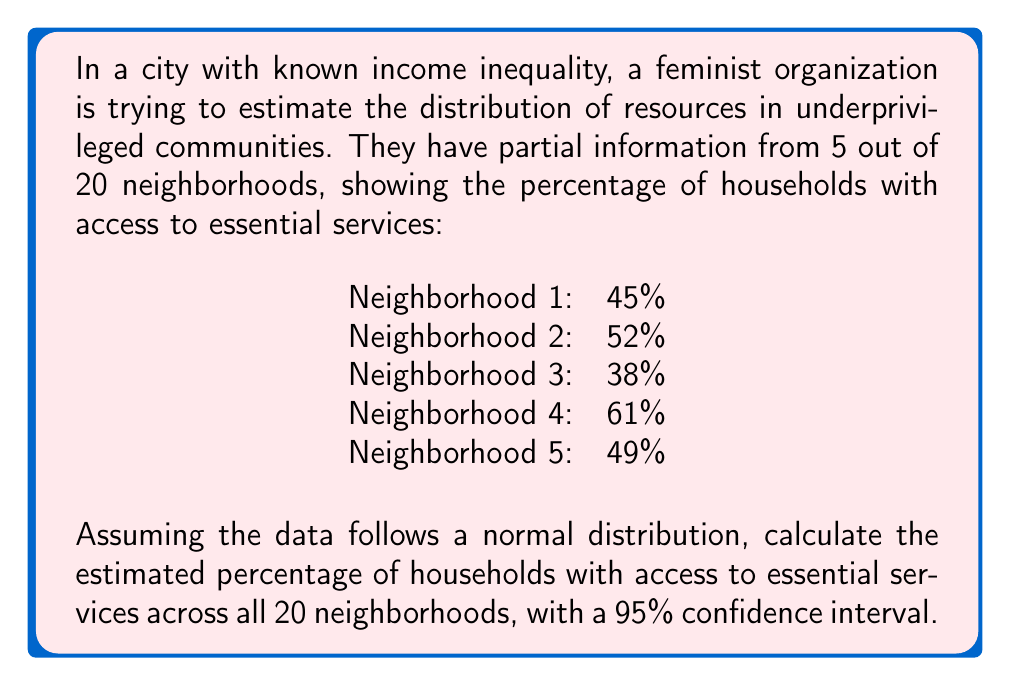Provide a solution to this math problem. To solve this problem, we'll use the following steps:

1. Calculate the mean ($\bar{x}$) of the sample data:
   $$\bar{x} = \frac{45 + 52 + 38 + 61 + 49}{5} = 49$$

2. Calculate the sample standard deviation ($s$):
   $$s = \sqrt{\frac{\sum_{i=1}^{n} (x_i - \bar{x})^2}{n - 1}}$$
   $$s = \sqrt{\frac{(45-49)^2 + (52-49)^2 + (38-49)^2 + (61-49)^2 + (49-49)^2}{5 - 1}} \approx 8.54$$

3. Determine the critical value ($t$) for a 95% confidence interval with 4 degrees of freedom:
   $t_{0.025, 4} = 2.776$ (from t-distribution table)

4. Calculate the margin of error (MOE):
   $$\text{MOE} = t \cdot \frac{s}{\sqrt{n}} = 2.776 \cdot \frac{8.54}{\sqrt{5}} \approx 10.60$$

5. Construct the 95% confidence interval:
   $$\text{CI} = \bar{x} \pm \text{MOE} = 49 \pm 10.60$$
   $$\text{CI} = (38.40, 59.60)$$

Therefore, we can estimate with 95% confidence that the percentage of households with access to essential services across all 20 neighborhoods is between 38.40% and 59.60%, with a point estimate of 49%.
Answer: 49% (95% CI: 38.40% - 59.60%) 